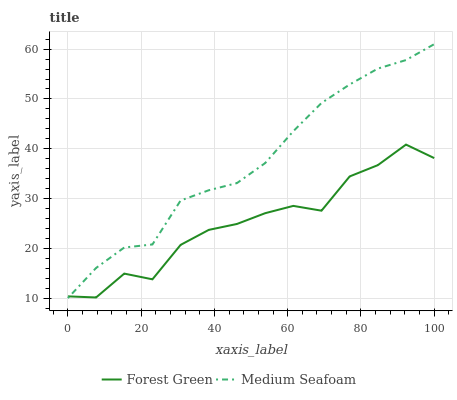Does Forest Green have the minimum area under the curve?
Answer yes or no. Yes. Does Medium Seafoam have the maximum area under the curve?
Answer yes or no. Yes. Does Medium Seafoam have the minimum area under the curve?
Answer yes or no. No. Is Medium Seafoam the smoothest?
Answer yes or no. Yes. Is Forest Green the roughest?
Answer yes or no. Yes. Is Medium Seafoam the roughest?
Answer yes or no. No. Does Medium Seafoam have the lowest value?
Answer yes or no. Yes. Does Medium Seafoam have the highest value?
Answer yes or no. Yes. Does Medium Seafoam intersect Forest Green?
Answer yes or no. Yes. Is Medium Seafoam less than Forest Green?
Answer yes or no. No. Is Medium Seafoam greater than Forest Green?
Answer yes or no. No. 